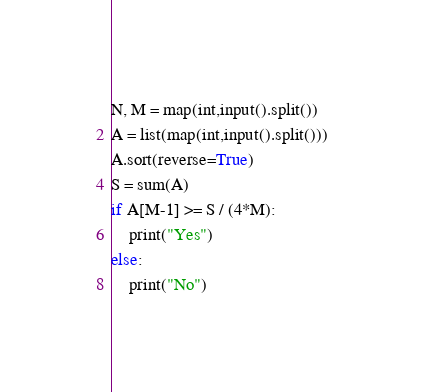<code> <loc_0><loc_0><loc_500><loc_500><_Python_>N, M = map(int,input().split())
A = list(map(int,input().split()))
A.sort(reverse=True)
S = sum(A)
if A[M-1] >= S / (4*M):
    print("Yes")
else:
    print("No")</code> 